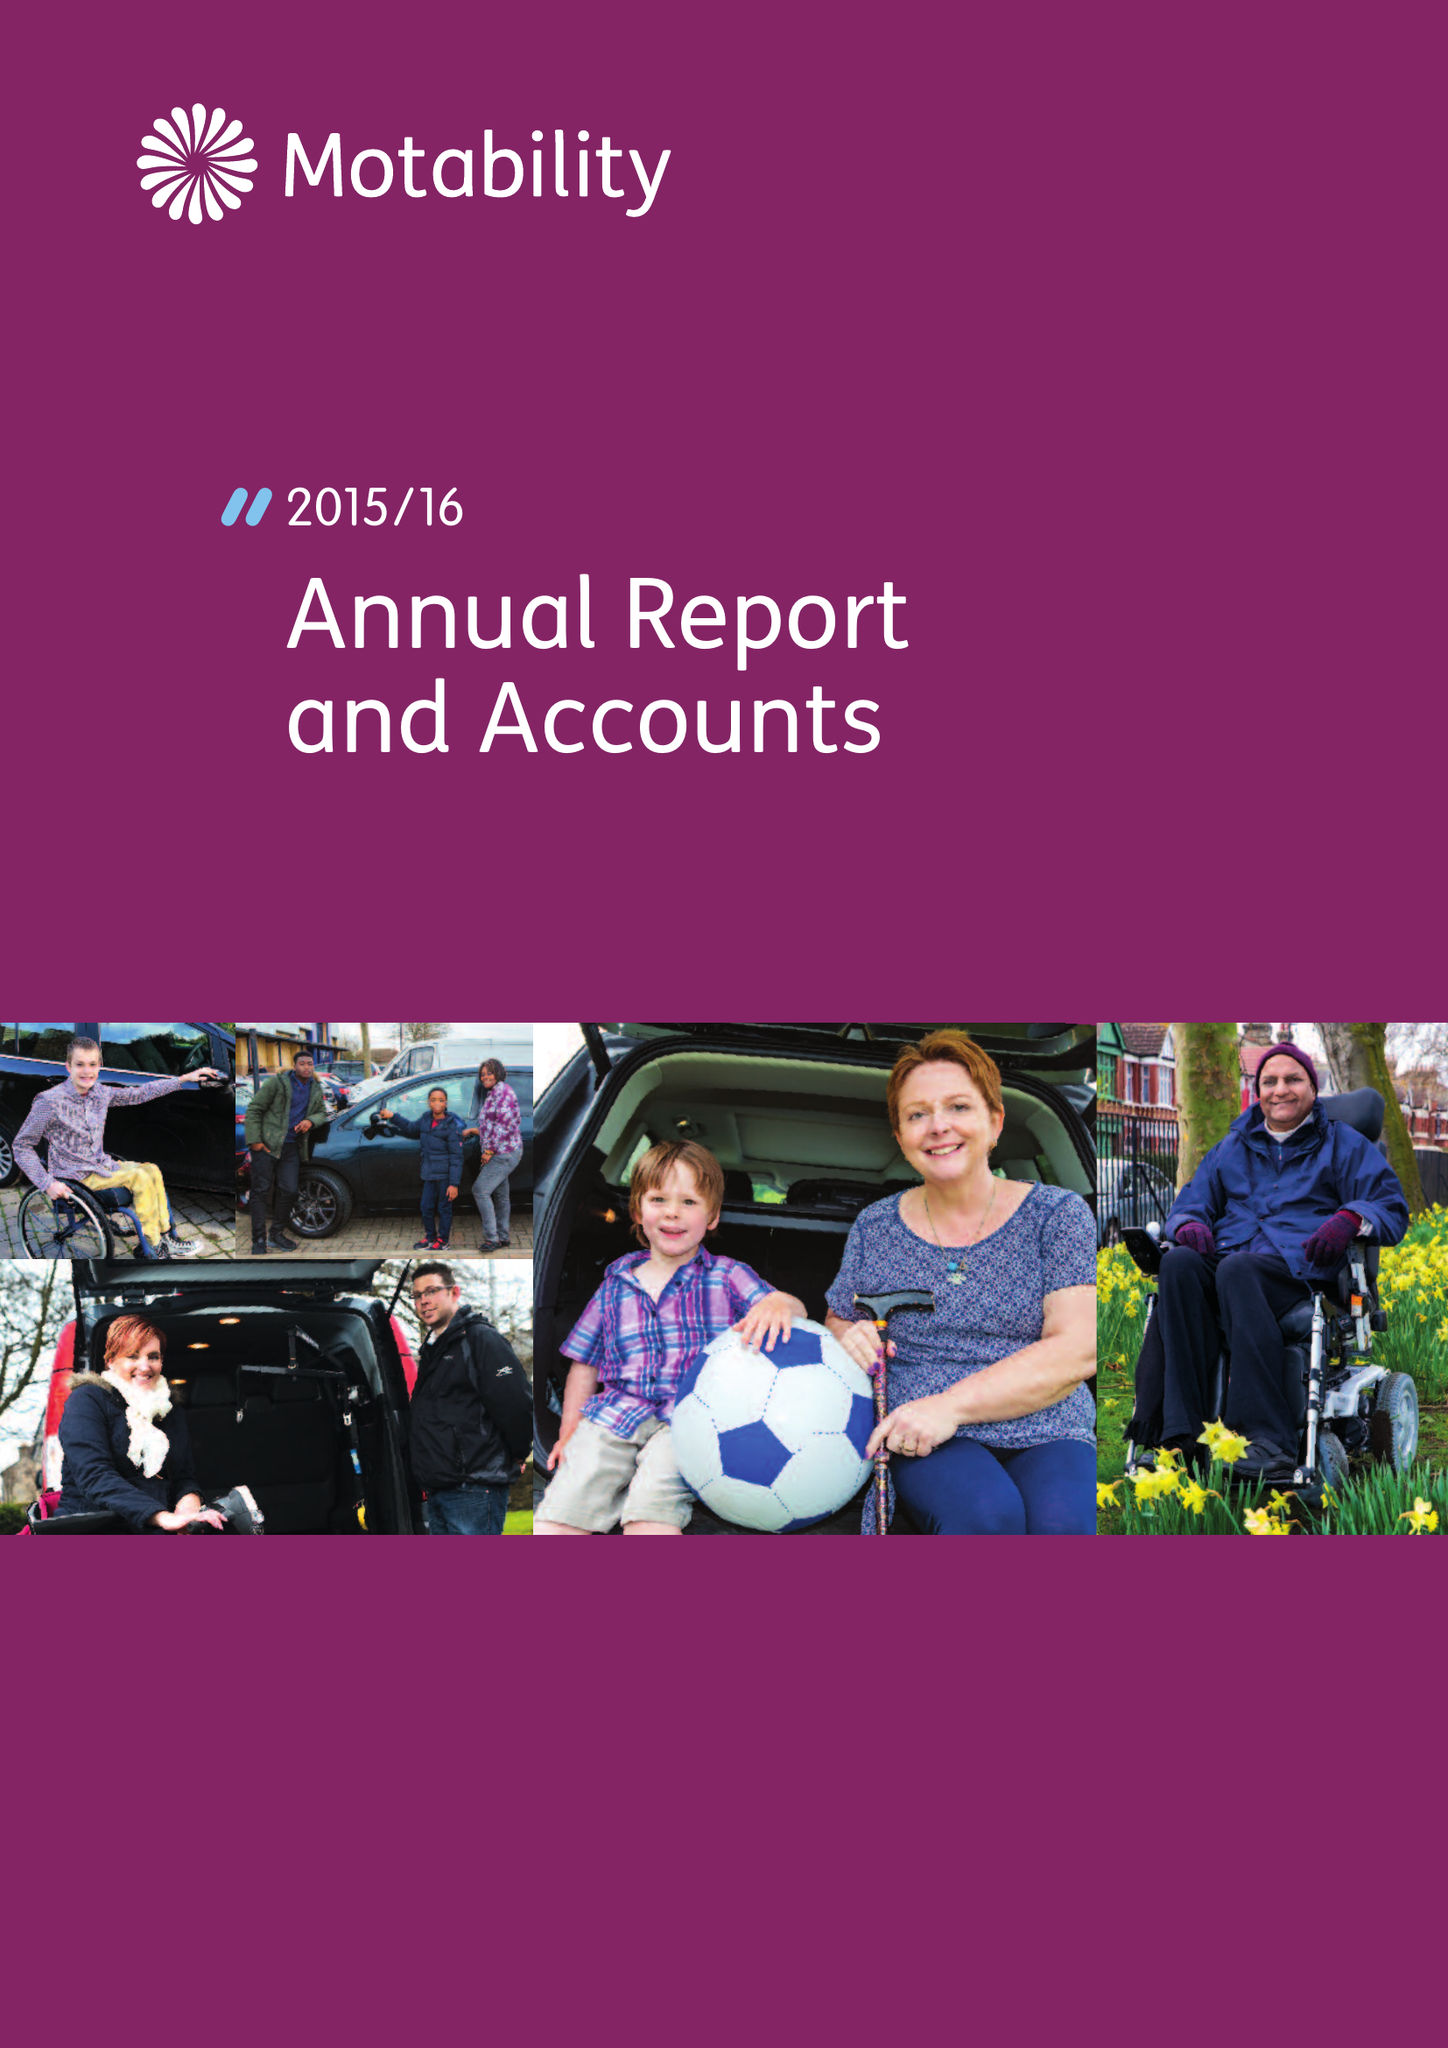What is the value for the address__post_town?
Answer the question using a single word or phrase. HARLOW 